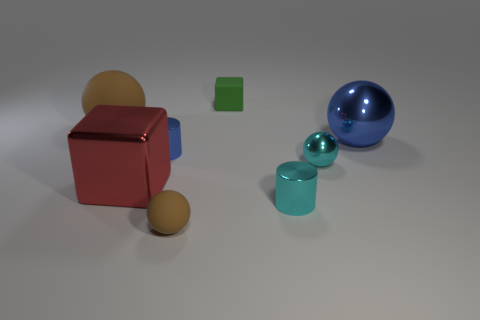Add 1 big gray metallic blocks. How many objects exist? 9 Subtract all blue metallic spheres. How many spheres are left? 3 Subtract 1 cubes. How many cubes are left? 1 Subtract all blue spheres. How many spheres are left? 3 Subtract 0 gray balls. How many objects are left? 8 Subtract all cylinders. How many objects are left? 6 Subtract all cyan blocks. Subtract all gray cylinders. How many blocks are left? 2 Subtract all purple balls. How many gray cubes are left? 0 Subtract all big metallic things. Subtract all tiny cyan shiny cylinders. How many objects are left? 5 Add 8 tiny cyan shiny things. How many tiny cyan shiny things are left? 10 